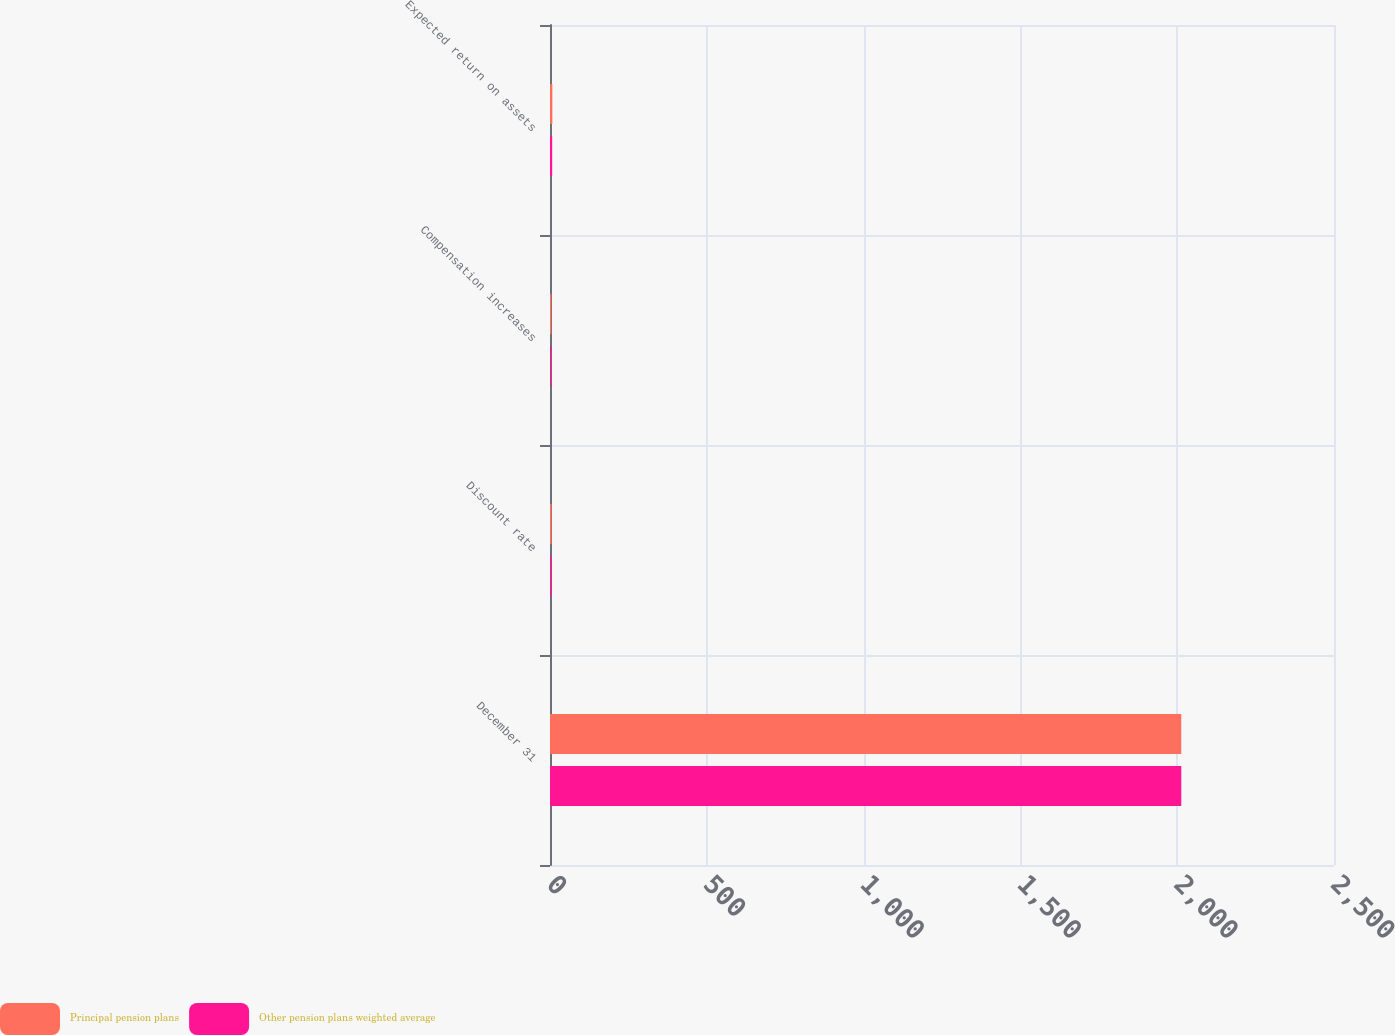Convert chart. <chart><loc_0><loc_0><loc_500><loc_500><stacked_bar_chart><ecel><fcel>December 31<fcel>Discount rate<fcel>Compensation increases<fcel>Expected return on assets<nl><fcel>Principal pension plans<fcel>2013<fcel>4.85<fcel>4<fcel>7.5<nl><fcel>Other pension plans weighted average<fcel>2013<fcel>4.39<fcel>3.76<fcel>6.92<nl></chart> 